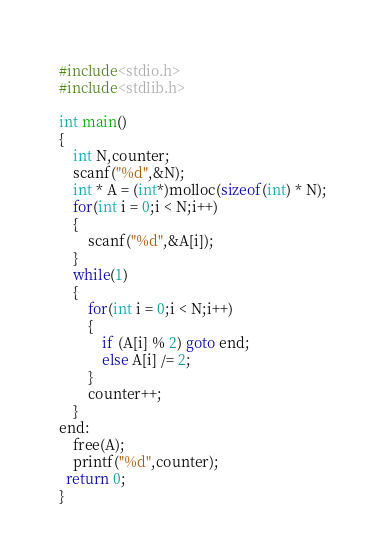Convert code to text. <code><loc_0><loc_0><loc_500><loc_500><_C_>#include<stdio.h>
#include<stdlib.h>

int main()
{
	int N,counter;
	scanf("%d",&N);
	int * A = (int*)molloc(sizeof(int) * N);
	for(int i = 0;i < N;i++)
	{
		scanf("%d",&A[i]);
	}
	while(1)
	{
		for(int i = 0;i < N;i++)
		{
			if (A[i] % 2) goto end;
			else A[i] /= 2;
		}
		counter++;
	}
end:
	free(A);
	printf("%d",counter);
  return 0;
}
</code> 